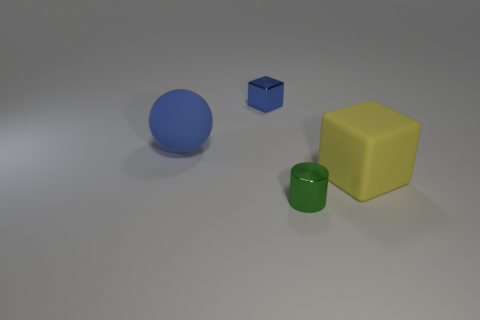Is there any other thing that has the same shape as the green thing?
Your response must be concise. No. How many balls are large blue objects or large yellow things?
Your response must be concise. 1. Does the green shiny thing have the same shape as the big matte thing on the left side of the tiny blue object?
Offer a terse response. No. What is the size of the thing that is both on the left side of the small green shiny object and on the right side of the matte sphere?
Make the answer very short. Small. The large yellow rubber thing has what shape?
Provide a short and direct response. Cube. Are there any tiny green cylinders that are right of the large object left of the green thing?
Ensure brevity in your answer.  Yes. How many things are behind the big thing on the left side of the yellow block?
Make the answer very short. 1. There is a yellow thing that is the same size as the blue sphere; what is it made of?
Ensure brevity in your answer.  Rubber. There is a object that is right of the green object; is its shape the same as the small green metallic object?
Offer a very short reply. No. Is the number of rubber things on the right side of the tiny blue cube greater than the number of big spheres that are in front of the yellow matte thing?
Ensure brevity in your answer.  Yes. 